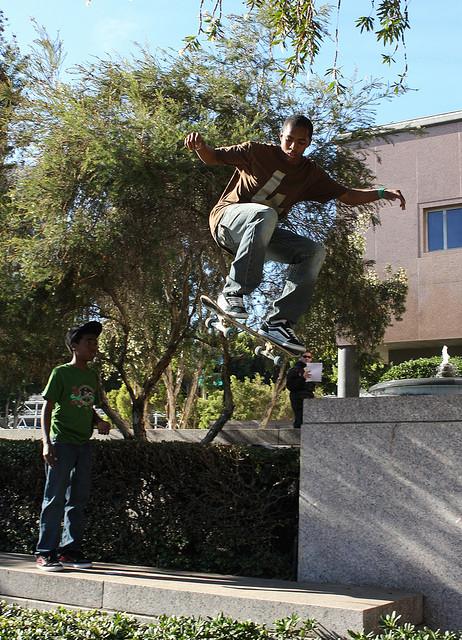Why is one boy in the air?
Keep it brief. Skateboarding. How many boys are shown?
Be succinct. 2. Does this boy have long hair?
Short answer required. No. What is the boy in back watching?
Give a very brief answer. Skateboarder. 